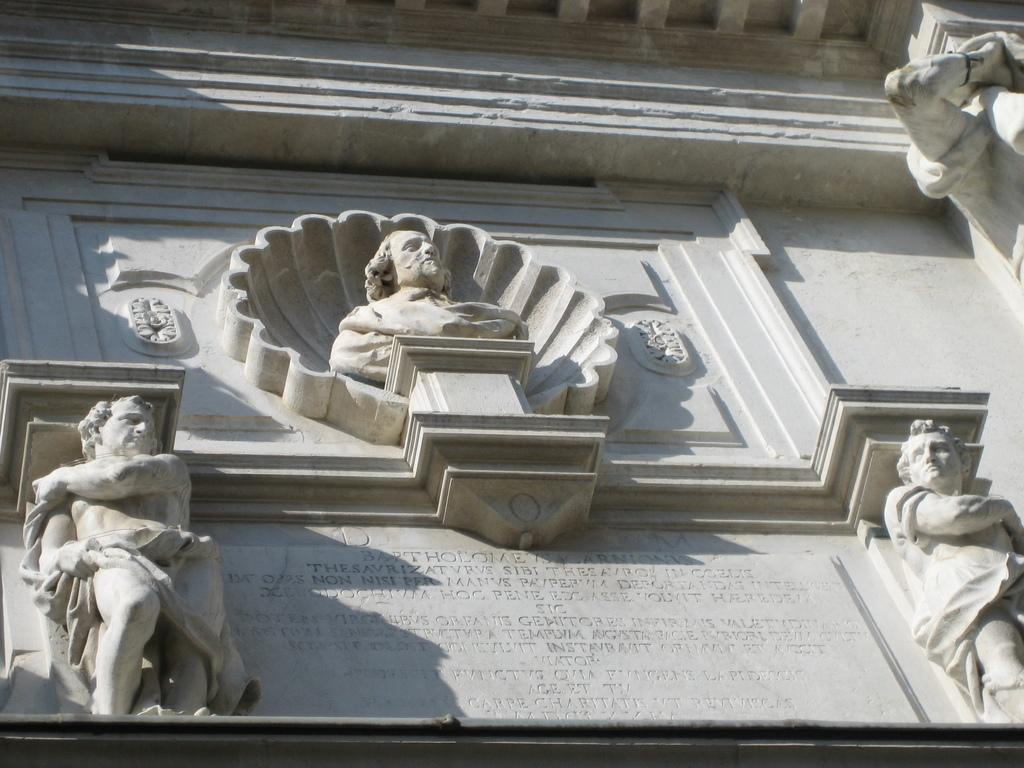What type of art is present in the image? There are sculptures in the image. How many toads are sitting on the sculptures in the image? There are no toads present in the image; it only features sculptures. What type of stitch is used to create the sculptures in the image? The sculptures in the image are not created using stitching; they are likely made of a solid material like stone or metal. 